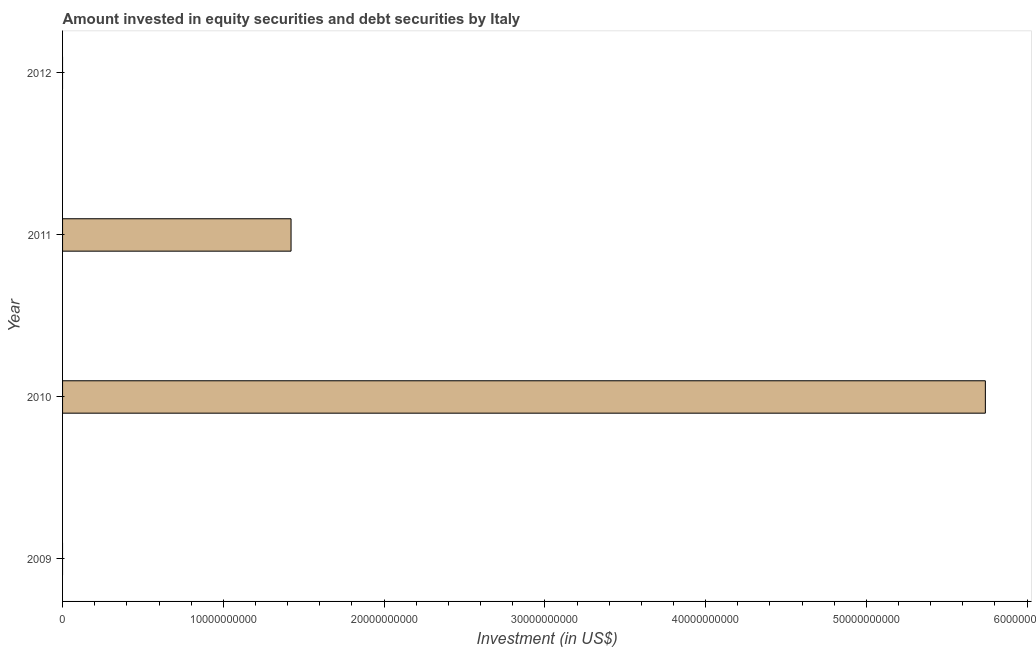Does the graph contain any zero values?
Provide a short and direct response. Yes. What is the title of the graph?
Your answer should be compact. Amount invested in equity securities and debt securities by Italy. What is the label or title of the X-axis?
Your answer should be compact. Investment (in US$). What is the label or title of the Y-axis?
Provide a short and direct response. Year. Across all years, what is the maximum portfolio investment?
Make the answer very short. 5.74e+1. In which year was the portfolio investment maximum?
Your answer should be very brief. 2010. What is the sum of the portfolio investment?
Your answer should be compact. 7.16e+1. What is the difference between the portfolio investment in 2010 and 2011?
Ensure brevity in your answer.  4.32e+1. What is the average portfolio investment per year?
Offer a terse response. 1.79e+1. What is the median portfolio investment?
Your answer should be compact. 7.11e+09. Is the portfolio investment in 2010 less than that in 2011?
Provide a succinct answer. No. What is the difference between the highest and the lowest portfolio investment?
Your answer should be very brief. 5.74e+1. How many bars are there?
Offer a very short reply. 2. Are all the bars in the graph horizontal?
Provide a succinct answer. Yes. How many years are there in the graph?
Give a very brief answer. 4. Are the values on the major ticks of X-axis written in scientific E-notation?
Your response must be concise. No. What is the Investment (in US$) in 2010?
Provide a short and direct response. 5.74e+1. What is the Investment (in US$) in 2011?
Keep it short and to the point. 1.42e+1. What is the difference between the Investment (in US$) in 2010 and 2011?
Keep it short and to the point. 4.32e+1. What is the ratio of the Investment (in US$) in 2010 to that in 2011?
Provide a short and direct response. 4.04. 